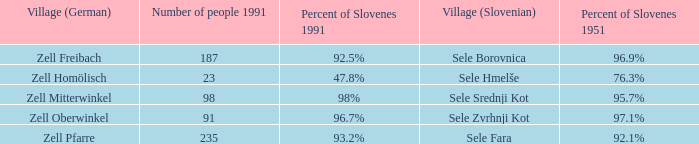Give me the minimum number of people in 1991 with 92.5% of Slovenes in 1991. 187.0. Parse the table in full. {'header': ['Village (German)', 'Number of people 1991', 'Percent of Slovenes 1991', 'Village (Slovenian)', 'Percent of Slovenes 1951'], 'rows': [['Zell Freibach', '187', '92.5%', 'Sele Borovnica', '96.9%'], ['Zell Homölisch', '23', '47.8%', 'Sele Hmelše', '76.3%'], ['Zell Mitterwinkel', '98', '98%', 'Sele Srednji Kot', '95.7%'], ['Zell Oberwinkel', '91', '96.7%', 'Sele Zvrhnji Kot', '97.1%'], ['Zell Pfarre', '235', '93.2%', 'Sele Fara', '92.1%']]} 